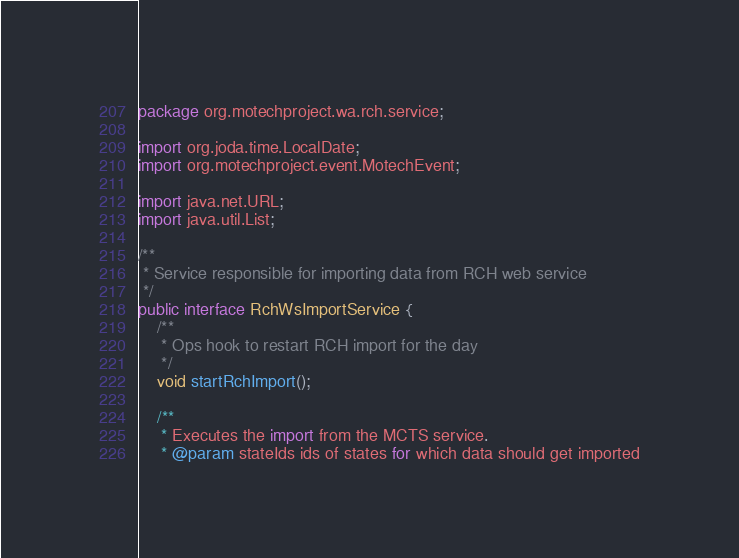<code> <loc_0><loc_0><loc_500><loc_500><_Java_>package org.motechproject.wa.rch.service;

import org.joda.time.LocalDate;
import org.motechproject.event.MotechEvent;

import java.net.URL;
import java.util.List;

/**
 * Service responsible for importing data from RCH web service
 */
public interface RchWsImportService {
    /**
     * Ops hook to restart RCH import for the day
     */
    void startRchImport();

    /**
     * Executes the import from the MCTS service.
     * @param stateIds ids of states for which data should get imported</code> 